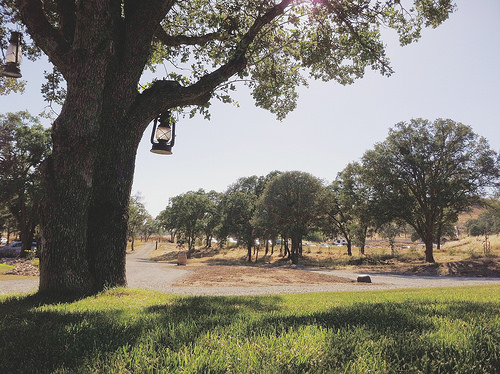<image>
Is the lantern on the road? No. The lantern is not positioned on the road. They may be near each other, but the lantern is not supported by or resting on top of the road. 